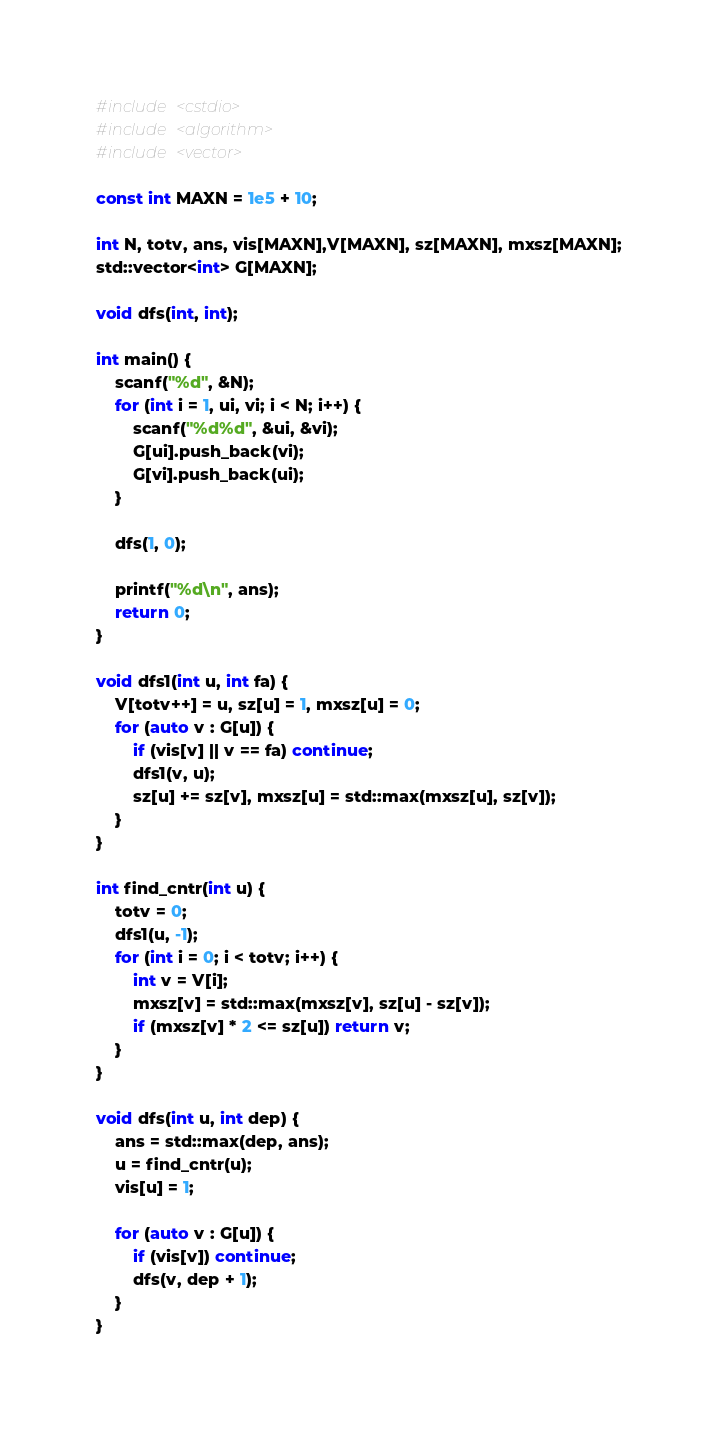<code> <loc_0><loc_0><loc_500><loc_500><_C++_>#include <cstdio>
#include <algorithm>
#include <vector>

const int MAXN = 1e5 + 10;

int N, totv, ans, vis[MAXN],V[MAXN], sz[MAXN], mxsz[MAXN];
std::vector<int> G[MAXN];

void dfs(int, int);

int main() {
	scanf("%d", &N);
	for (int i = 1, ui, vi; i < N; i++) {
		scanf("%d%d", &ui, &vi);
		G[ui].push_back(vi);
		G[vi].push_back(ui);
	}

	dfs(1, 0);

	printf("%d\n", ans);
	return 0;
}

void dfs1(int u, int fa) {
	V[totv++] = u, sz[u] = 1, mxsz[u] = 0;
	for (auto v : G[u]) {
		if (vis[v] || v == fa) continue;
		dfs1(v, u);
		sz[u] += sz[v], mxsz[u] = std::max(mxsz[u], sz[v]);
	}
}

int find_cntr(int u) {
	totv = 0;
	dfs1(u, -1);
	for (int i = 0; i < totv; i++) {
		int v = V[i];
		mxsz[v] = std::max(mxsz[v], sz[u] - sz[v]);
		if (mxsz[v] * 2 <= sz[u]) return v;
	}
}

void dfs(int u, int dep) {
	ans = std::max(dep, ans);
	u = find_cntr(u);
	vis[u] = 1;
	
	for (auto v : G[u]) {
		if (vis[v]) continue;
		dfs(v, dep + 1);
	}
}</code> 